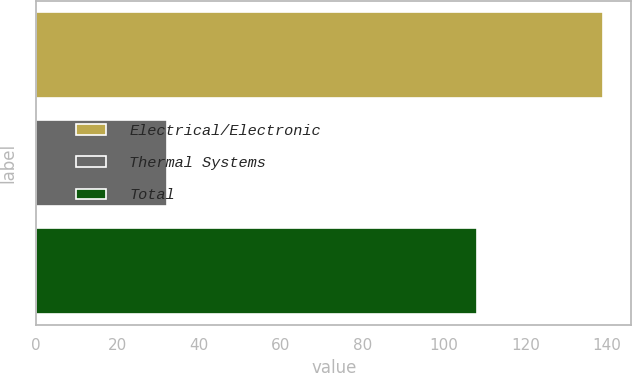<chart> <loc_0><loc_0><loc_500><loc_500><bar_chart><fcel>Electrical/Electronic<fcel>Thermal Systems<fcel>Total<nl><fcel>139<fcel>32<fcel>108<nl></chart> 